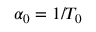Convert formula to latex. <formula><loc_0><loc_0><loc_500><loc_500>\alpha _ { 0 } = 1 / T _ { 0 }</formula> 